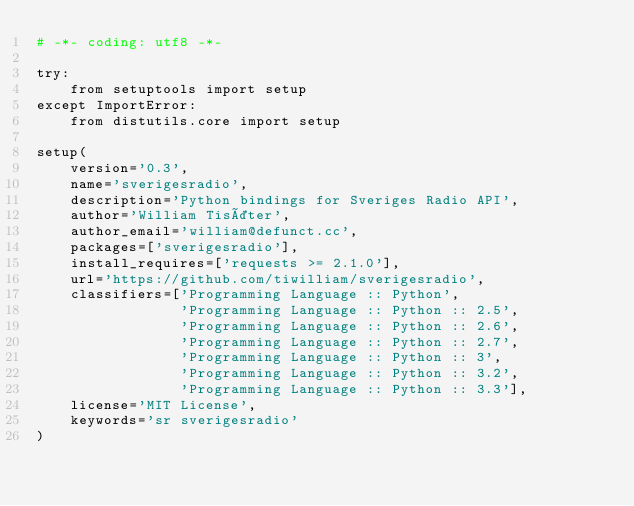<code> <loc_0><loc_0><loc_500><loc_500><_Python_># -*- coding: utf8 -*-

try:
    from setuptools import setup
except ImportError:
    from distutils.core import setup

setup(
    version='0.3',
    name='sverigesradio',
    description='Python bindings for Sveriges Radio API',
    author='William Tisäter',
    author_email='william@defunct.cc',
    packages=['sverigesradio'],
    install_requires=['requests >= 2.1.0'],
    url='https://github.com/tiwilliam/sverigesradio',
    classifiers=['Programming Language :: Python',
                 'Programming Language :: Python :: 2.5',
                 'Programming Language :: Python :: 2.6',
                 'Programming Language :: Python :: 2.7',
                 'Programming Language :: Python :: 3',
                 'Programming Language :: Python :: 3.2',
                 'Programming Language :: Python :: 3.3'],
    license='MIT License',
    keywords='sr sverigesradio'
)
</code> 